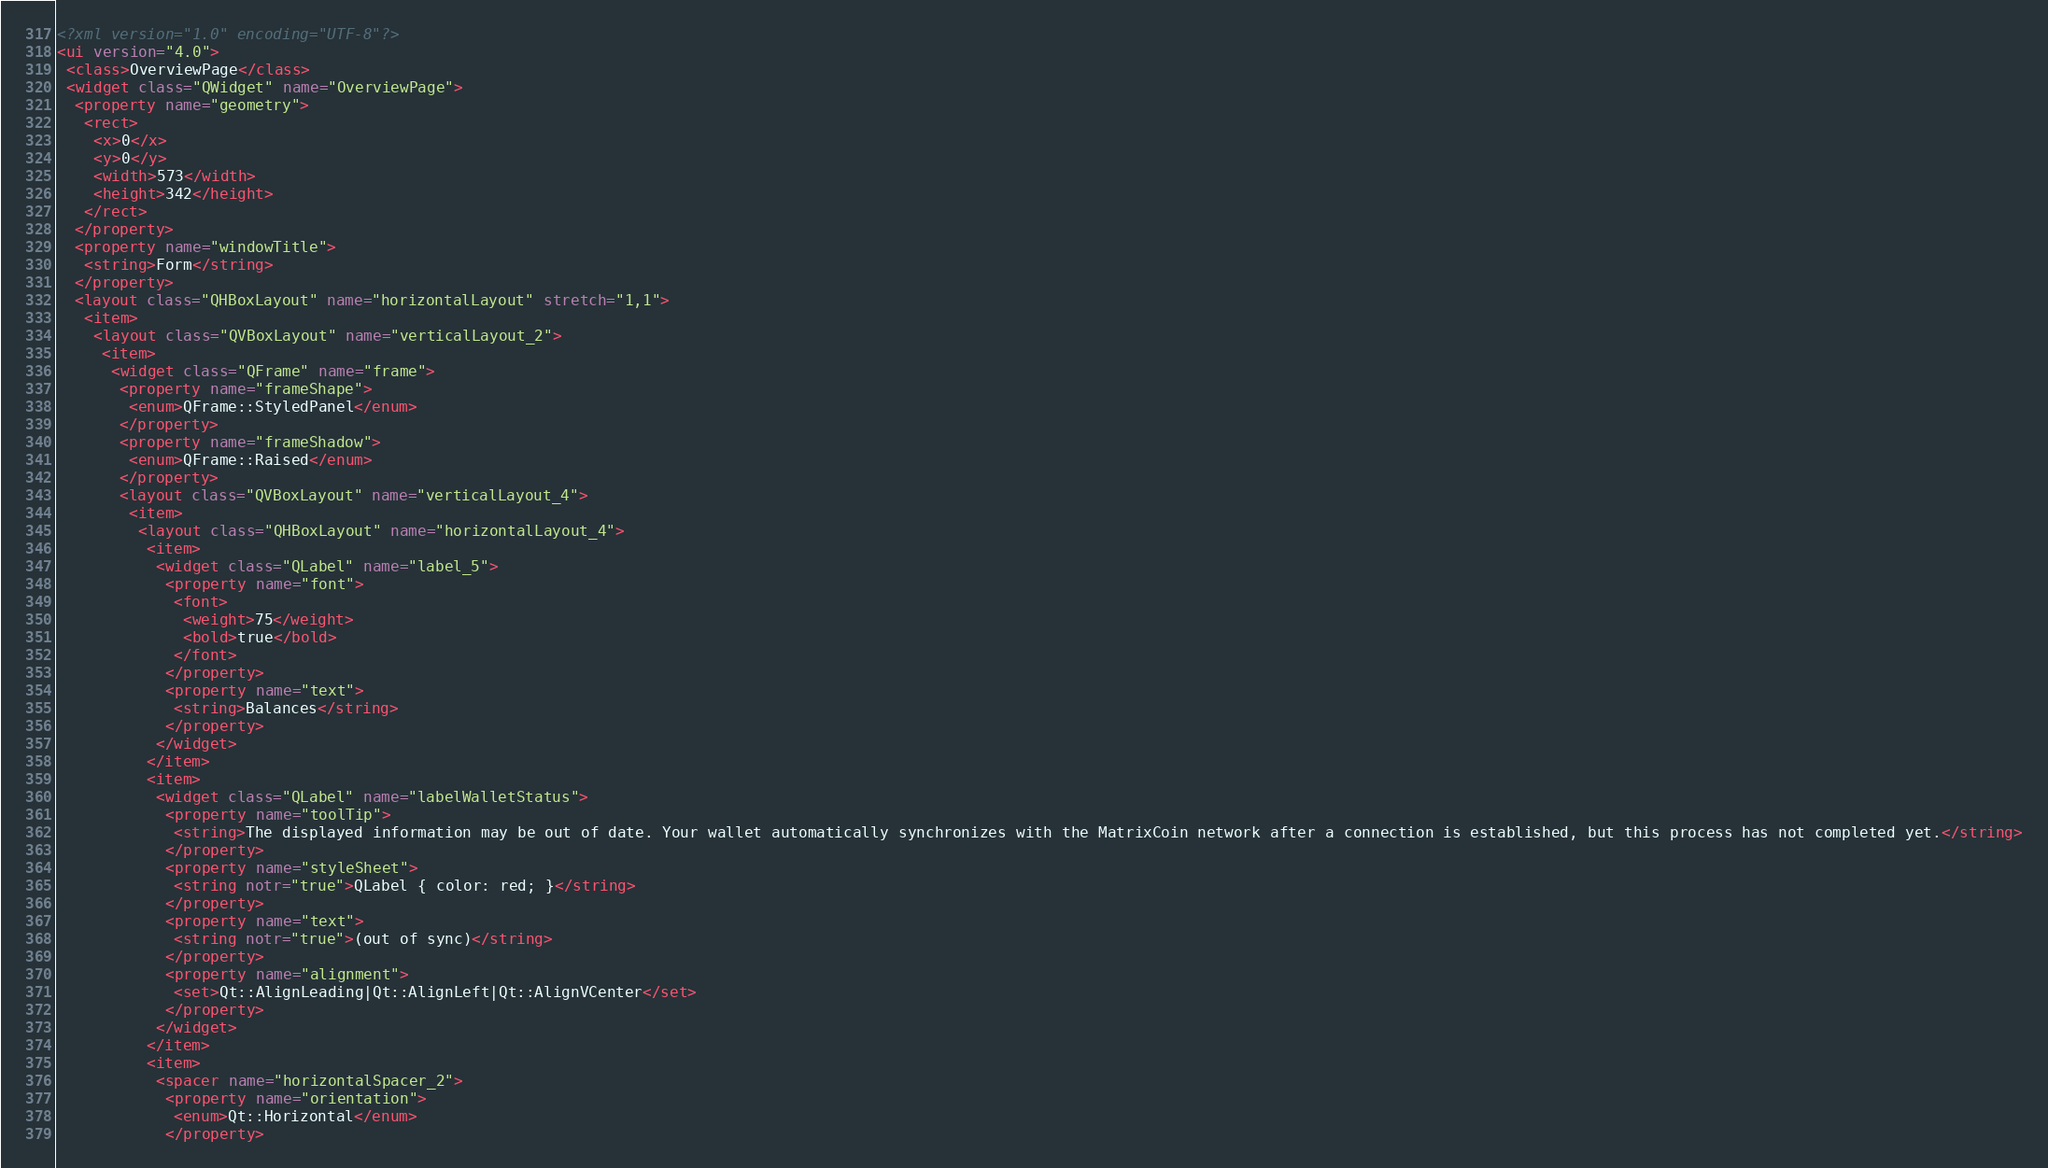<code> <loc_0><loc_0><loc_500><loc_500><_XML_><?xml version="1.0" encoding="UTF-8"?>
<ui version="4.0">
 <class>OverviewPage</class>
 <widget class="QWidget" name="OverviewPage">
  <property name="geometry">
   <rect>
    <x>0</x>
    <y>0</y>
    <width>573</width>
    <height>342</height>
   </rect>
  </property>
  <property name="windowTitle">
   <string>Form</string>
  </property>
  <layout class="QHBoxLayout" name="horizontalLayout" stretch="1,1">
   <item>
    <layout class="QVBoxLayout" name="verticalLayout_2">
     <item>
      <widget class="QFrame" name="frame">
       <property name="frameShape">
        <enum>QFrame::StyledPanel</enum>
       </property>
       <property name="frameShadow">
        <enum>QFrame::Raised</enum>
       </property>
       <layout class="QVBoxLayout" name="verticalLayout_4">
        <item>
         <layout class="QHBoxLayout" name="horizontalLayout_4">
          <item>
           <widget class="QLabel" name="label_5">
            <property name="font">
             <font>
              <weight>75</weight>
              <bold>true</bold>
             </font>
            </property>
            <property name="text">
             <string>Balances</string>
            </property>
           </widget>
          </item>
          <item>
           <widget class="QLabel" name="labelWalletStatus">
            <property name="toolTip">
             <string>The displayed information may be out of date. Your wallet automatically synchronizes with the MatrixCoin network after a connection is established, but this process has not completed yet.</string>
            </property>
            <property name="styleSheet">
             <string notr="true">QLabel { color: red; }</string>
            </property>
            <property name="text">
             <string notr="true">(out of sync)</string>
            </property>
            <property name="alignment">
             <set>Qt::AlignLeading|Qt::AlignLeft|Qt::AlignVCenter</set>
            </property>
           </widget>
          </item>
          <item>
           <spacer name="horizontalSpacer_2">
            <property name="orientation">
             <enum>Qt::Horizontal</enum>
            </property></code> 